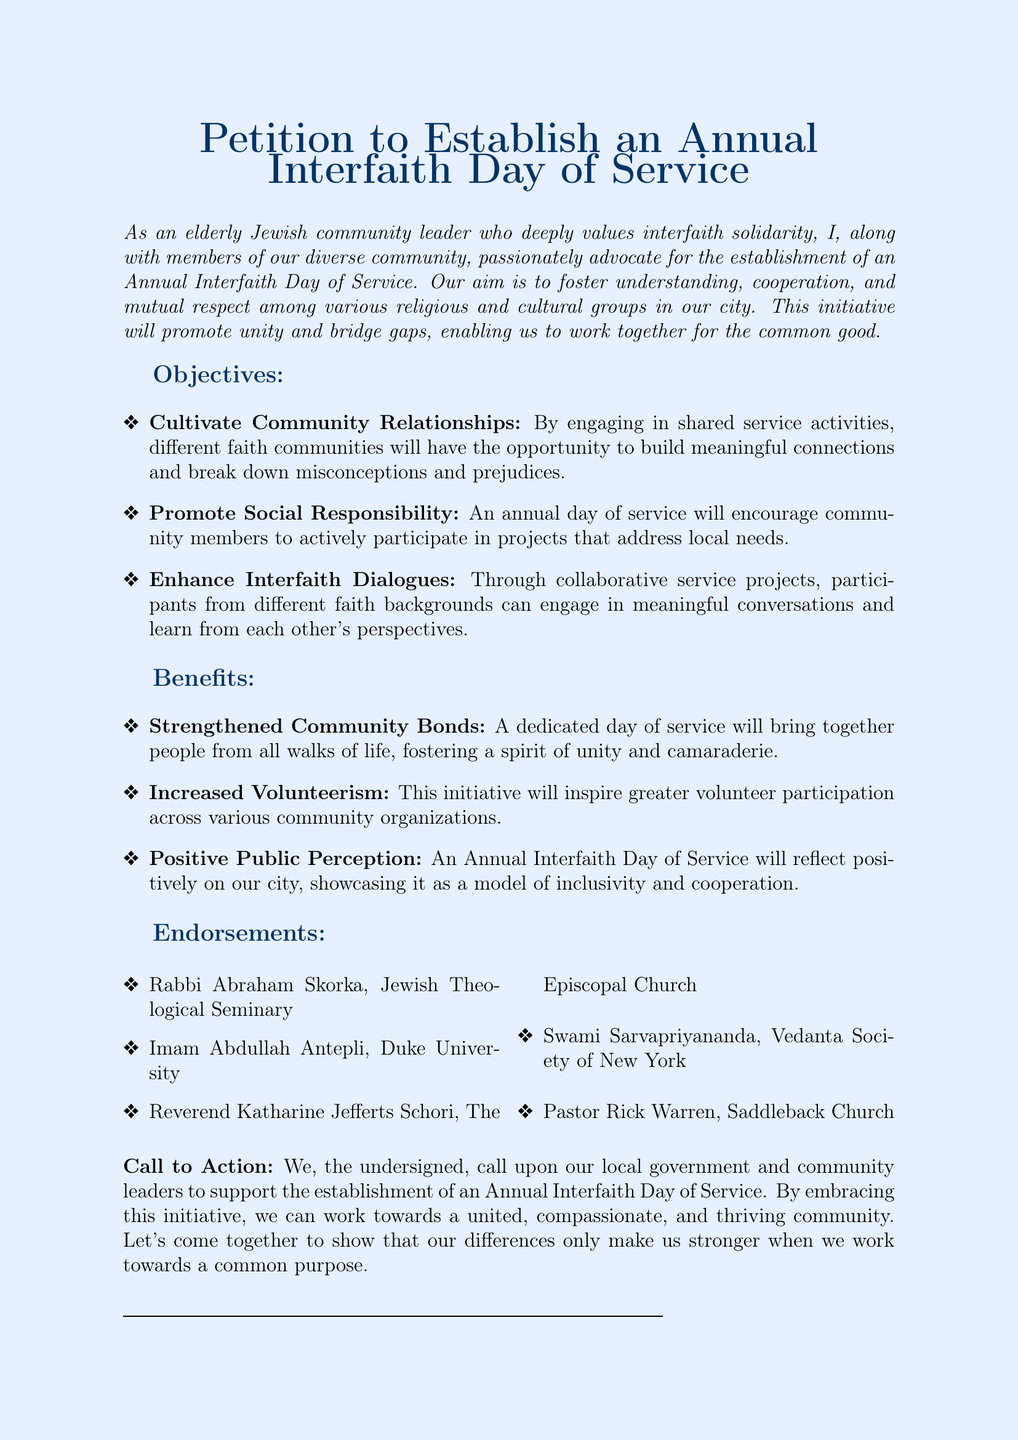What is the title of the petition? The title at the beginning of the document states the purpose, which is to establish an Annual Interfaith Day of Service.
Answer: Petition to Establish an Annual Interfaith Day of Service Who is the author of the petition? The author identifies as an elderly Jewish community leader, suggesting their role in the document.
Answer: Elderly Jewish community leader What is one objective of the petition? The document lists objectives aimed at fostering community relationships among different faiths, and one of these is stated directly.
Answer: Cultivate Community Relationships Name one benefit mentioned in the petition. The petition outlines various benefits, and one is explicitly described in the document.
Answer: Strengthened Community Bonds How many endorsements are listed in the petition? The document features endorsements from various religious leaders, and counting them provides the answer.
Answer: Five What type of action is requested from the local government? The call to action in the document specifically requests support from local government and community leaders.
Answer: Support Which religious leader from the endorsements is associated with the Jewish Theological Seminary? One of the endorsers is identified with their affiliated institution in the list.
Answer: Rabbi Abraham Skorka What is the main goal of the Annual Interfaith Day of Service? The overall aim presented in the document articulates fostering understanding and cooperation among different groups.
Answer: Strengthen community bonds 